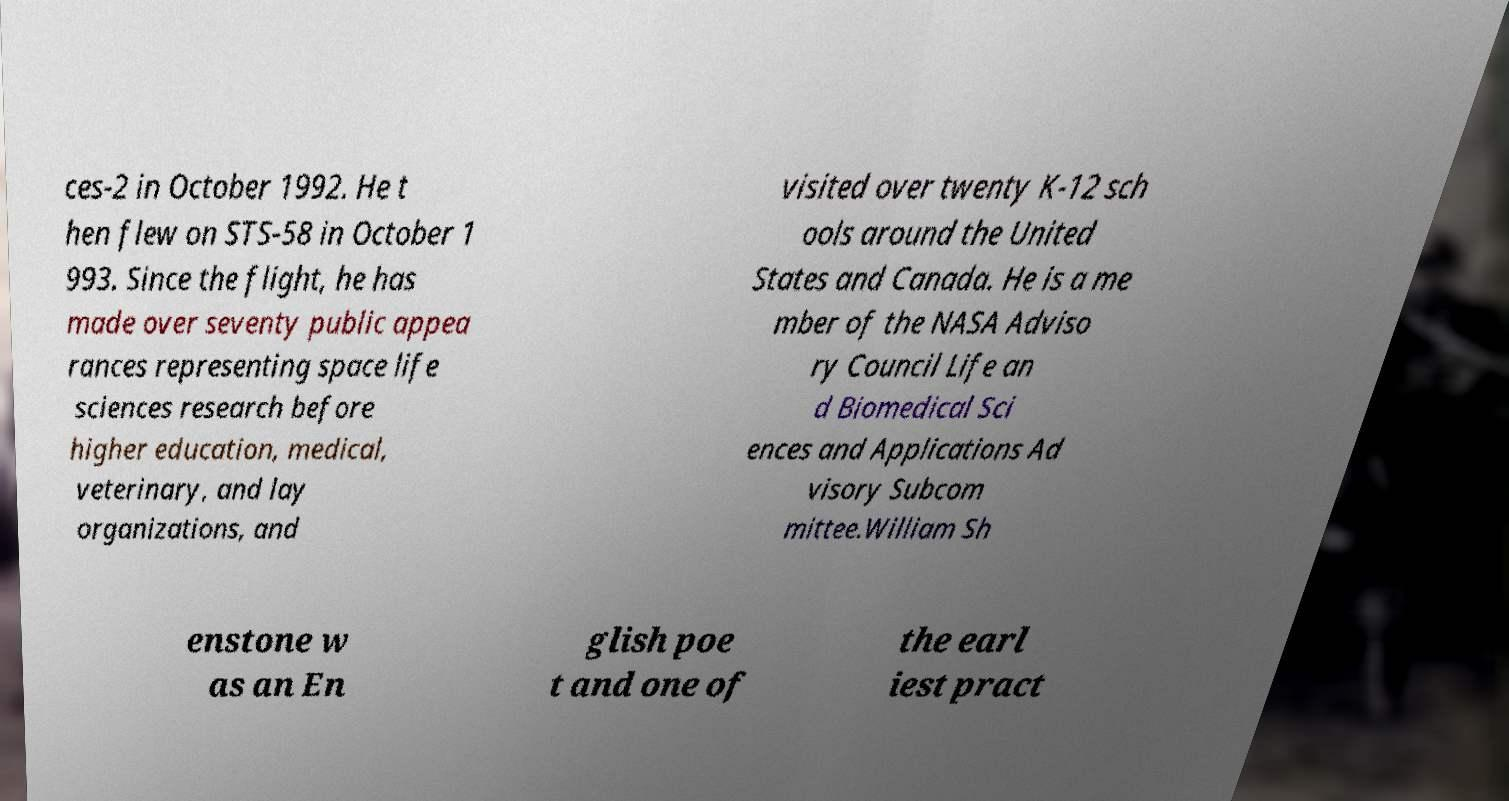Please identify and transcribe the text found in this image. ces-2 in October 1992. He t hen flew on STS-58 in October 1 993. Since the flight, he has made over seventy public appea rances representing space life sciences research before higher education, medical, veterinary, and lay organizations, and visited over twenty K-12 sch ools around the United States and Canada. He is a me mber of the NASA Adviso ry Council Life an d Biomedical Sci ences and Applications Ad visory Subcom mittee.William Sh enstone w as an En glish poe t and one of the earl iest pract 